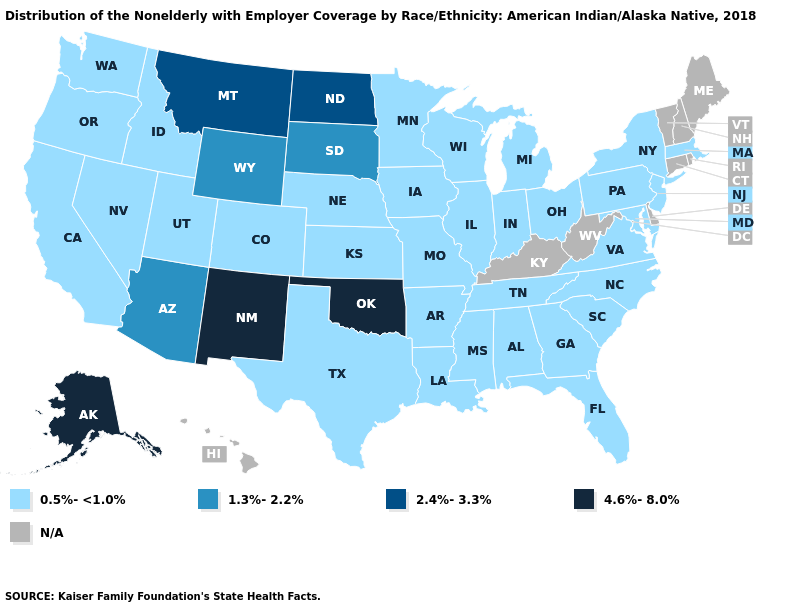Among the states that border Texas , which have the highest value?
Write a very short answer. New Mexico, Oklahoma. Among the states that border Wyoming , does Montana have the highest value?
Quick response, please. Yes. What is the value of Georgia?
Concise answer only. 0.5%-<1.0%. What is the highest value in states that border Wisconsin?
Quick response, please. 0.5%-<1.0%. Does the first symbol in the legend represent the smallest category?
Answer briefly. Yes. Name the states that have a value in the range 1.3%-2.2%?
Concise answer only. Arizona, South Dakota, Wyoming. Name the states that have a value in the range 1.3%-2.2%?
Write a very short answer. Arizona, South Dakota, Wyoming. What is the value of Arkansas?
Keep it brief. 0.5%-<1.0%. Name the states that have a value in the range 4.6%-8.0%?
Write a very short answer. Alaska, New Mexico, Oklahoma. Does Oklahoma have the lowest value in the South?
Write a very short answer. No. Name the states that have a value in the range 0.5%-<1.0%?
Answer briefly. Alabama, Arkansas, California, Colorado, Florida, Georgia, Idaho, Illinois, Indiana, Iowa, Kansas, Louisiana, Maryland, Massachusetts, Michigan, Minnesota, Mississippi, Missouri, Nebraska, Nevada, New Jersey, New York, North Carolina, Ohio, Oregon, Pennsylvania, South Carolina, Tennessee, Texas, Utah, Virginia, Washington, Wisconsin. Does the first symbol in the legend represent the smallest category?
Give a very brief answer. Yes. Name the states that have a value in the range N/A?
Quick response, please. Connecticut, Delaware, Hawaii, Kentucky, Maine, New Hampshire, Rhode Island, Vermont, West Virginia. Does New Mexico have the highest value in the USA?
Answer briefly. Yes. What is the highest value in the South ?
Answer briefly. 4.6%-8.0%. 